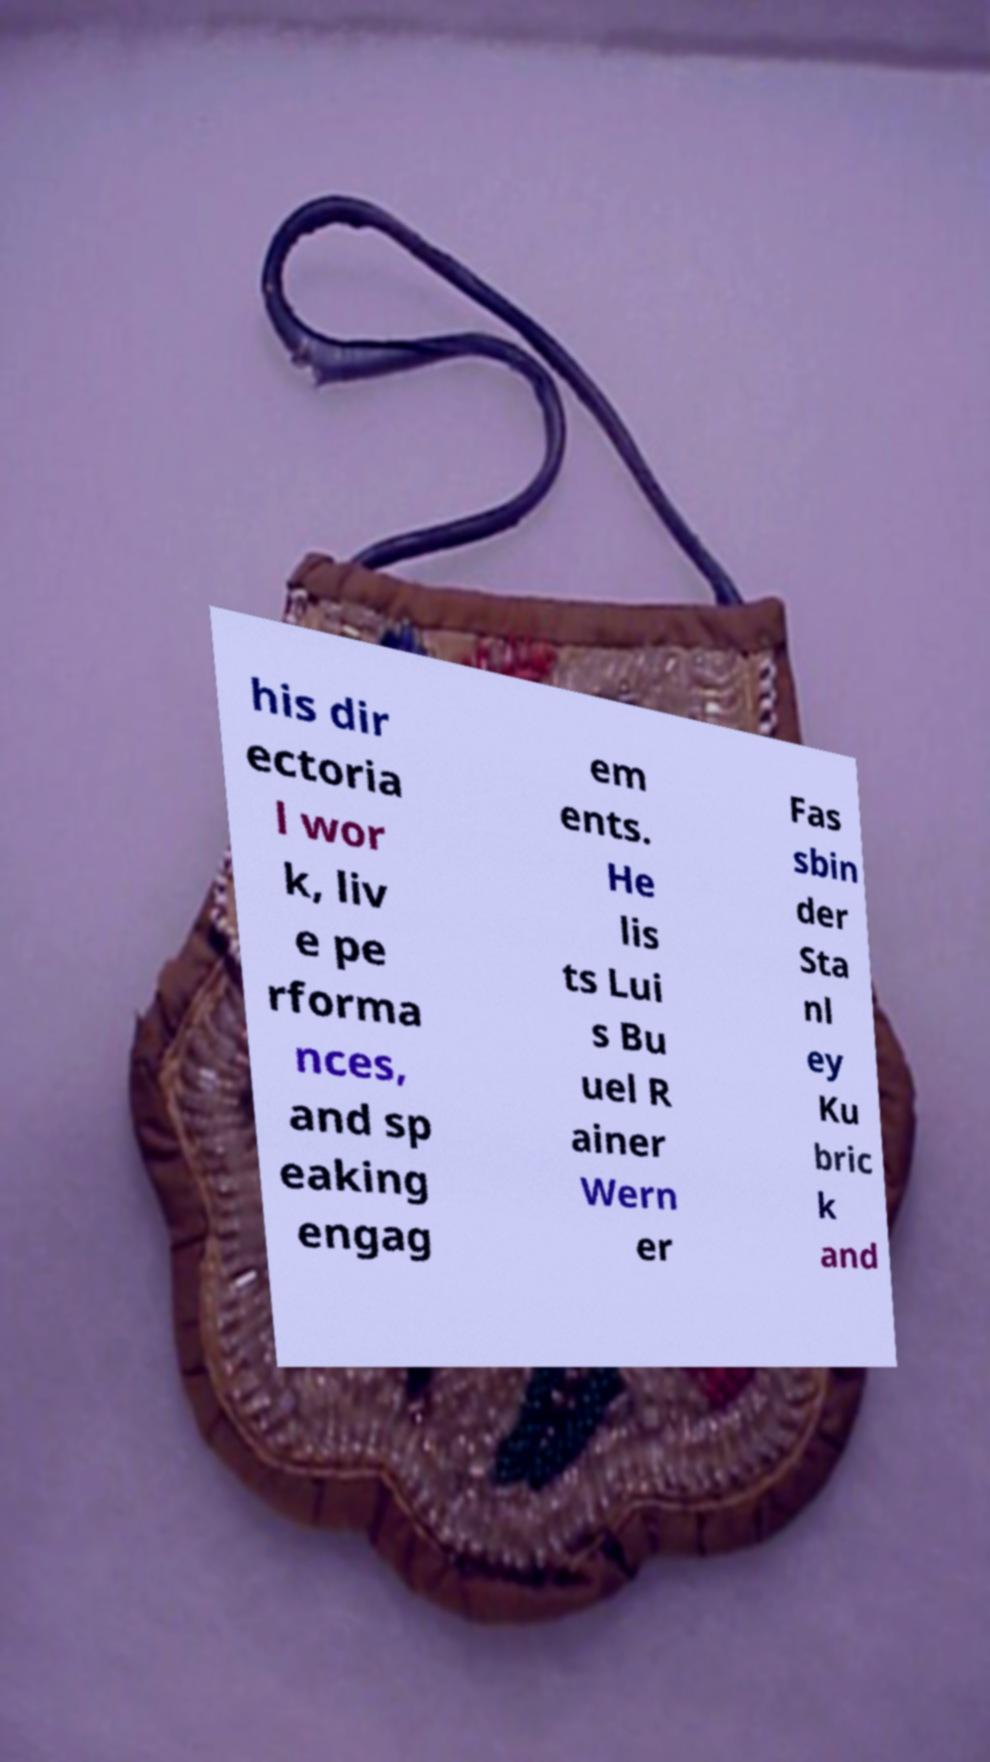Could you extract and type out the text from this image? his dir ectoria l wor k, liv e pe rforma nces, and sp eaking engag em ents. He lis ts Lui s Bu uel R ainer Wern er Fas sbin der Sta nl ey Ku bric k and 